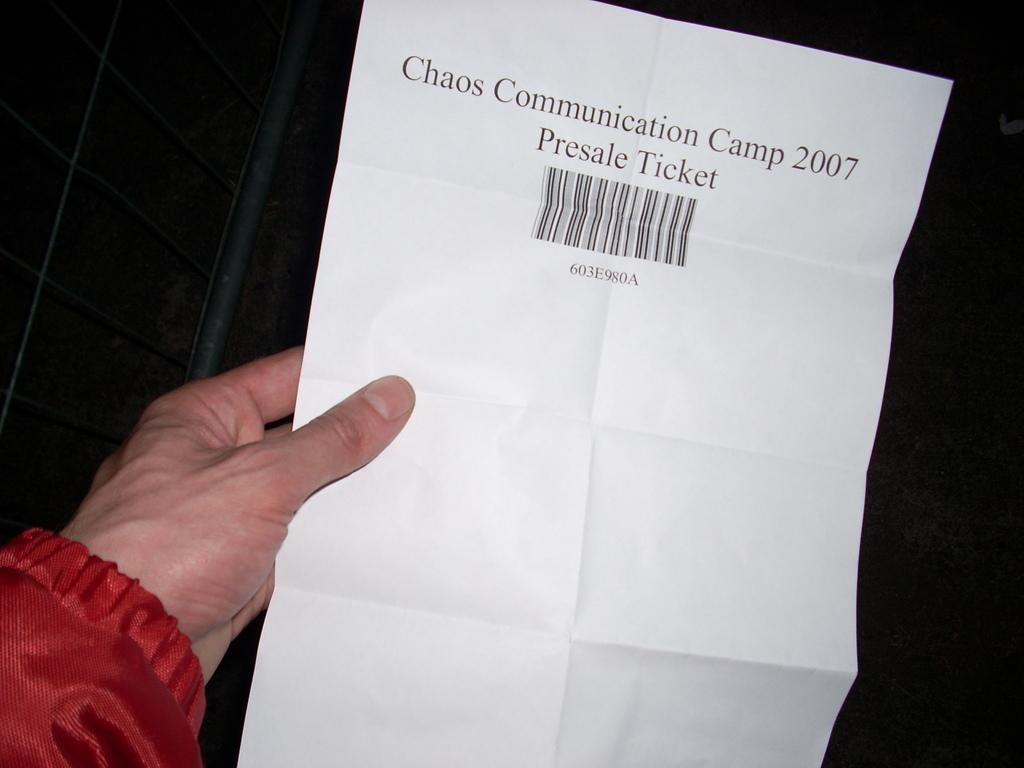What is the human hand holding in the image? The human hand is holding a paper in the image. What can be found on the paper? The paper has text and a barcode on it. What is the color of the background in the image? The background of the image is black. How many loaves of bread are visible in the image? There are no loaves of bread present in the image. What type of connection can be seen between the cars in the image? There are no cars present in the image, so no connection can be observed. 